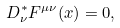<formula> <loc_0><loc_0><loc_500><loc_500>D _ { \nu } ^ { * } F ^ { \mu \nu } ( x ) = 0 ,</formula> 